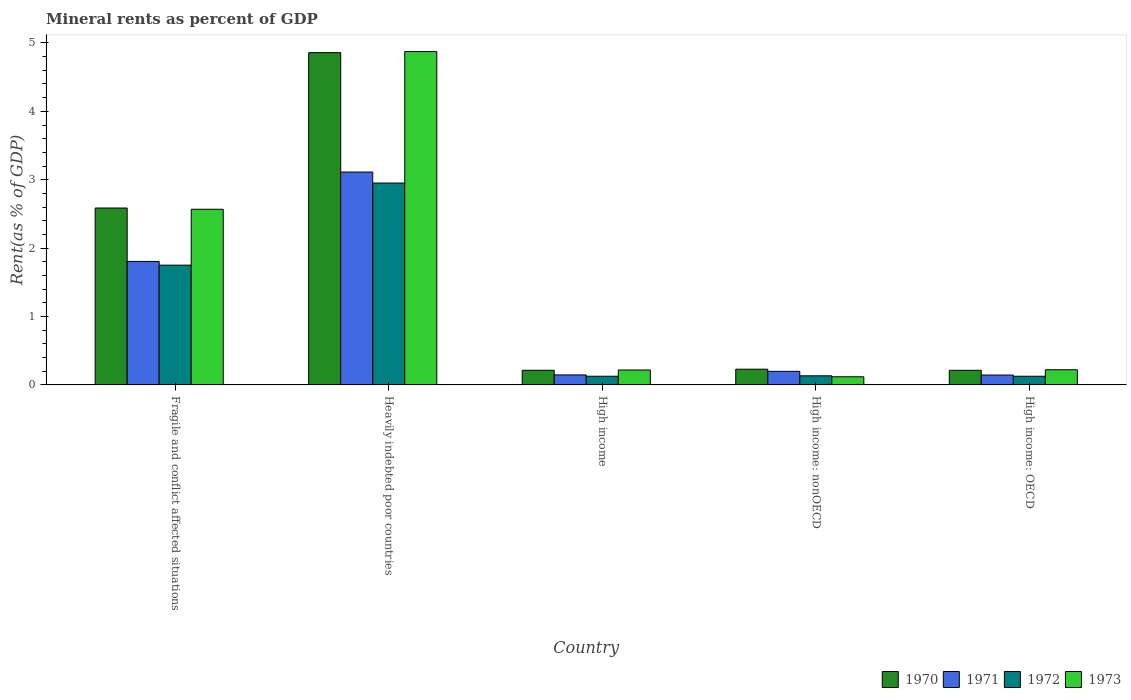Are the number of bars on each tick of the X-axis equal?
Ensure brevity in your answer.  Yes. What is the label of the 4th group of bars from the left?
Your answer should be compact. High income: nonOECD. What is the mineral rent in 1973 in High income: OECD?
Offer a very short reply. 0.22. Across all countries, what is the maximum mineral rent in 1972?
Give a very brief answer. 2.95. Across all countries, what is the minimum mineral rent in 1971?
Offer a terse response. 0.14. In which country was the mineral rent in 1970 maximum?
Your answer should be compact. Heavily indebted poor countries. In which country was the mineral rent in 1972 minimum?
Provide a succinct answer. High income: OECD. What is the total mineral rent in 1971 in the graph?
Provide a succinct answer. 5.41. What is the difference between the mineral rent in 1973 in Heavily indebted poor countries and that in High income: nonOECD?
Your answer should be compact. 4.75. What is the difference between the mineral rent in 1973 in High income and the mineral rent in 1970 in High income: OECD?
Provide a short and direct response. 0. What is the average mineral rent in 1973 per country?
Provide a succinct answer. 1.6. What is the difference between the mineral rent of/in 1972 and mineral rent of/in 1971 in Fragile and conflict affected situations?
Provide a succinct answer. -0.05. In how many countries, is the mineral rent in 1971 greater than 1.4 %?
Your answer should be compact. 2. What is the ratio of the mineral rent in 1973 in High income to that in High income: nonOECD?
Keep it short and to the point. 1.83. Is the mineral rent in 1970 in Heavily indebted poor countries less than that in High income: nonOECD?
Provide a short and direct response. No. Is the difference between the mineral rent in 1972 in Fragile and conflict affected situations and High income: OECD greater than the difference between the mineral rent in 1971 in Fragile and conflict affected situations and High income: OECD?
Provide a short and direct response. No. What is the difference between the highest and the second highest mineral rent in 1971?
Offer a terse response. -1.61. What is the difference between the highest and the lowest mineral rent in 1971?
Your answer should be very brief. 2.97. In how many countries, is the mineral rent in 1973 greater than the average mineral rent in 1973 taken over all countries?
Offer a very short reply. 2. Is the sum of the mineral rent in 1971 in Fragile and conflict affected situations and High income: OECD greater than the maximum mineral rent in 1970 across all countries?
Your answer should be compact. No. Is it the case that in every country, the sum of the mineral rent in 1973 and mineral rent in 1972 is greater than the sum of mineral rent in 1970 and mineral rent in 1971?
Offer a terse response. No. What does the 4th bar from the right in High income: OECD represents?
Give a very brief answer. 1970. Is it the case that in every country, the sum of the mineral rent in 1971 and mineral rent in 1973 is greater than the mineral rent in 1972?
Provide a short and direct response. Yes. Are all the bars in the graph horizontal?
Your answer should be very brief. No. What is the difference between two consecutive major ticks on the Y-axis?
Make the answer very short. 1. Does the graph contain any zero values?
Your answer should be compact. No. Where does the legend appear in the graph?
Ensure brevity in your answer.  Bottom right. How many legend labels are there?
Offer a very short reply. 4. How are the legend labels stacked?
Ensure brevity in your answer.  Horizontal. What is the title of the graph?
Offer a very short reply. Mineral rents as percent of GDP. What is the label or title of the Y-axis?
Provide a succinct answer. Rent(as % of GDP). What is the Rent(as % of GDP) of 1970 in Fragile and conflict affected situations?
Your answer should be compact. 2.59. What is the Rent(as % of GDP) in 1971 in Fragile and conflict affected situations?
Ensure brevity in your answer.  1.81. What is the Rent(as % of GDP) of 1972 in Fragile and conflict affected situations?
Give a very brief answer. 1.75. What is the Rent(as % of GDP) in 1973 in Fragile and conflict affected situations?
Offer a very short reply. 2.57. What is the Rent(as % of GDP) in 1970 in Heavily indebted poor countries?
Make the answer very short. 4.86. What is the Rent(as % of GDP) in 1971 in Heavily indebted poor countries?
Ensure brevity in your answer.  3.11. What is the Rent(as % of GDP) in 1972 in Heavily indebted poor countries?
Ensure brevity in your answer.  2.95. What is the Rent(as % of GDP) in 1973 in Heavily indebted poor countries?
Ensure brevity in your answer.  4.87. What is the Rent(as % of GDP) of 1970 in High income?
Provide a short and direct response. 0.21. What is the Rent(as % of GDP) of 1971 in High income?
Provide a short and direct response. 0.15. What is the Rent(as % of GDP) in 1972 in High income?
Provide a short and direct response. 0.13. What is the Rent(as % of GDP) of 1973 in High income?
Your response must be concise. 0.22. What is the Rent(as % of GDP) in 1970 in High income: nonOECD?
Ensure brevity in your answer.  0.23. What is the Rent(as % of GDP) of 1971 in High income: nonOECD?
Your answer should be very brief. 0.2. What is the Rent(as % of GDP) of 1972 in High income: nonOECD?
Provide a succinct answer. 0.13. What is the Rent(as % of GDP) in 1973 in High income: nonOECD?
Provide a short and direct response. 0.12. What is the Rent(as % of GDP) of 1970 in High income: OECD?
Provide a short and direct response. 0.21. What is the Rent(as % of GDP) of 1971 in High income: OECD?
Provide a short and direct response. 0.14. What is the Rent(as % of GDP) of 1972 in High income: OECD?
Provide a short and direct response. 0.13. What is the Rent(as % of GDP) of 1973 in High income: OECD?
Provide a short and direct response. 0.22. Across all countries, what is the maximum Rent(as % of GDP) in 1970?
Your response must be concise. 4.86. Across all countries, what is the maximum Rent(as % of GDP) of 1971?
Your answer should be compact. 3.11. Across all countries, what is the maximum Rent(as % of GDP) in 1972?
Your answer should be compact. 2.95. Across all countries, what is the maximum Rent(as % of GDP) in 1973?
Provide a succinct answer. 4.87. Across all countries, what is the minimum Rent(as % of GDP) in 1970?
Your response must be concise. 0.21. Across all countries, what is the minimum Rent(as % of GDP) in 1971?
Offer a very short reply. 0.14. Across all countries, what is the minimum Rent(as % of GDP) of 1972?
Give a very brief answer. 0.13. Across all countries, what is the minimum Rent(as % of GDP) of 1973?
Provide a succinct answer. 0.12. What is the total Rent(as % of GDP) in 1970 in the graph?
Ensure brevity in your answer.  8.1. What is the total Rent(as % of GDP) in 1971 in the graph?
Ensure brevity in your answer.  5.41. What is the total Rent(as % of GDP) in 1972 in the graph?
Give a very brief answer. 5.09. What is the total Rent(as % of GDP) in 1973 in the graph?
Your answer should be very brief. 8. What is the difference between the Rent(as % of GDP) in 1970 in Fragile and conflict affected situations and that in Heavily indebted poor countries?
Your answer should be very brief. -2.27. What is the difference between the Rent(as % of GDP) of 1971 in Fragile and conflict affected situations and that in Heavily indebted poor countries?
Offer a terse response. -1.31. What is the difference between the Rent(as % of GDP) in 1972 in Fragile and conflict affected situations and that in Heavily indebted poor countries?
Give a very brief answer. -1.2. What is the difference between the Rent(as % of GDP) in 1973 in Fragile and conflict affected situations and that in Heavily indebted poor countries?
Offer a terse response. -2.31. What is the difference between the Rent(as % of GDP) in 1970 in Fragile and conflict affected situations and that in High income?
Make the answer very short. 2.37. What is the difference between the Rent(as % of GDP) in 1971 in Fragile and conflict affected situations and that in High income?
Provide a short and direct response. 1.66. What is the difference between the Rent(as % of GDP) in 1972 in Fragile and conflict affected situations and that in High income?
Keep it short and to the point. 1.62. What is the difference between the Rent(as % of GDP) in 1973 in Fragile and conflict affected situations and that in High income?
Give a very brief answer. 2.35. What is the difference between the Rent(as % of GDP) of 1970 in Fragile and conflict affected situations and that in High income: nonOECD?
Keep it short and to the point. 2.36. What is the difference between the Rent(as % of GDP) of 1971 in Fragile and conflict affected situations and that in High income: nonOECD?
Give a very brief answer. 1.61. What is the difference between the Rent(as % of GDP) of 1972 in Fragile and conflict affected situations and that in High income: nonOECD?
Keep it short and to the point. 1.62. What is the difference between the Rent(as % of GDP) in 1973 in Fragile and conflict affected situations and that in High income: nonOECD?
Your response must be concise. 2.45. What is the difference between the Rent(as % of GDP) of 1970 in Fragile and conflict affected situations and that in High income: OECD?
Make the answer very short. 2.37. What is the difference between the Rent(as % of GDP) of 1971 in Fragile and conflict affected situations and that in High income: OECD?
Your response must be concise. 1.66. What is the difference between the Rent(as % of GDP) in 1972 in Fragile and conflict affected situations and that in High income: OECD?
Make the answer very short. 1.62. What is the difference between the Rent(as % of GDP) in 1973 in Fragile and conflict affected situations and that in High income: OECD?
Offer a terse response. 2.35. What is the difference between the Rent(as % of GDP) of 1970 in Heavily indebted poor countries and that in High income?
Provide a short and direct response. 4.64. What is the difference between the Rent(as % of GDP) of 1971 in Heavily indebted poor countries and that in High income?
Provide a succinct answer. 2.97. What is the difference between the Rent(as % of GDP) in 1972 in Heavily indebted poor countries and that in High income?
Your answer should be compact. 2.82. What is the difference between the Rent(as % of GDP) of 1973 in Heavily indebted poor countries and that in High income?
Offer a very short reply. 4.66. What is the difference between the Rent(as % of GDP) in 1970 in Heavily indebted poor countries and that in High income: nonOECD?
Make the answer very short. 4.63. What is the difference between the Rent(as % of GDP) in 1971 in Heavily indebted poor countries and that in High income: nonOECD?
Offer a terse response. 2.91. What is the difference between the Rent(as % of GDP) in 1972 in Heavily indebted poor countries and that in High income: nonOECD?
Your answer should be very brief. 2.82. What is the difference between the Rent(as % of GDP) in 1973 in Heavily indebted poor countries and that in High income: nonOECD?
Offer a terse response. 4.75. What is the difference between the Rent(as % of GDP) in 1970 in Heavily indebted poor countries and that in High income: OECD?
Keep it short and to the point. 4.64. What is the difference between the Rent(as % of GDP) of 1971 in Heavily indebted poor countries and that in High income: OECD?
Offer a terse response. 2.97. What is the difference between the Rent(as % of GDP) in 1972 in Heavily indebted poor countries and that in High income: OECD?
Ensure brevity in your answer.  2.83. What is the difference between the Rent(as % of GDP) of 1973 in Heavily indebted poor countries and that in High income: OECD?
Provide a succinct answer. 4.65. What is the difference between the Rent(as % of GDP) of 1970 in High income and that in High income: nonOECD?
Give a very brief answer. -0.02. What is the difference between the Rent(as % of GDP) in 1971 in High income and that in High income: nonOECD?
Your answer should be very brief. -0.05. What is the difference between the Rent(as % of GDP) of 1972 in High income and that in High income: nonOECD?
Provide a succinct answer. -0.01. What is the difference between the Rent(as % of GDP) of 1973 in High income and that in High income: nonOECD?
Provide a succinct answer. 0.1. What is the difference between the Rent(as % of GDP) in 1970 in High income and that in High income: OECD?
Offer a very short reply. 0. What is the difference between the Rent(as % of GDP) in 1971 in High income and that in High income: OECD?
Offer a very short reply. 0. What is the difference between the Rent(as % of GDP) of 1973 in High income and that in High income: OECD?
Your answer should be compact. -0. What is the difference between the Rent(as % of GDP) of 1970 in High income: nonOECD and that in High income: OECD?
Ensure brevity in your answer.  0.02. What is the difference between the Rent(as % of GDP) in 1971 in High income: nonOECD and that in High income: OECD?
Offer a very short reply. 0.05. What is the difference between the Rent(as % of GDP) in 1972 in High income: nonOECD and that in High income: OECD?
Offer a terse response. 0.01. What is the difference between the Rent(as % of GDP) of 1973 in High income: nonOECD and that in High income: OECD?
Your response must be concise. -0.1. What is the difference between the Rent(as % of GDP) of 1970 in Fragile and conflict affected situations and the Rent(as % of GDP) of 1971 in Heavily indebted poor countries?
Your response must be concise. -0.53. What is the difference between the Rent(as % of GDP) in 1970 in Fragile and conflict affected situations and the Rent(as % of GDP) in 1972 in Heavily indebted poor countries?
Ensure brevity in your answer.  -0.37. What is the difference between the Rent(as % of GDP) of 1970 in Fragile and conflict affected situations and the Rent(as % of GDP) of 1973 in Heavily indebted poor countries?
Offer a very short reply. -2.29. What is the difference between the Rent(as % of GDP) in 1971 in Fragile and conflict affected situations and the Rent(as % of GDP) in 1972 in Heavily indebted poor countries?
Your response must be concise. -1.15. What is the difference between the Rent(as % of GDP) of 1971 in Fragile and conflict affected situations and the Rent(as % of GDP) of 1973 in Heavily indebted poor countries?
Make the answer very short. -3.07. What is the difference between the Rent(as % of GDP) in 1972 in Fragile and conflict affected situations and the Rent(as % of GDP) in 1973 in Heavily indebted poor countries?
Keep it short and to the point. -3.12. What is the difference between the Rent(as % of GDP) of 1970 in Fragile and conflict affected situations and the Rent(as % of GDP) of 1971 in High income?
Your answer should be compact. 2.44. What is the difference between the Rent(as % of GDP) in 1970 in Fragile and conflict affected situations and the Rent(as % of GDP) in 1972 in High income?
Your answer should be very brief. 2.46. What is the difference between the Rent(as % of GDP) in 1970 in Fragile and conflict affected situations and the Rent(as % of GDP) in 1973 in High income?
Your response must be concise. 2.37. What is the difference between the Rent(as % of GDP) of 1971 in Fragile and conflict affected situations and the Rent(as % of GDP) of 1972 in High income?
Keep it short and to the point. 1.68. What is the difference between the Rent(as % of GDP) of 1971 in Fragile and conflict affected situations and the Rent(as % of GDP) of 1973 in High income?
Offer a very short reply. 1.59. What is the difference between the Rent(as % of GDP) of 1972 in Fragile and conflict affected situations and the Rent(as % of GDP) of 1973 in High income?
Your response must be concise. 1.53. What is the difference between the Rent(as % of GDP) of 1970 in Fragile and conflict affected situations and the Rent(as % of GDP) of 1971 in High income: nonOECD?
Provide a short and direct response. 2.39. What is the difference between the Rent(as % of GDP) in 1970 in Fragile and conflict affected situations and the Rent(as % of GDP) in 1972 in High income: nonOECD?
Your answer should be very brief. 2.45. What is the difference between the Rent(as % of GDP) in 1970 in Fragile and conflict affected situations and the Rent(as % of GDP) in 1973 in High income: nonOECD?
Offer a terse response. 2.47. What is the difference between the Rent(as % of GDP) in 1971 in Fragile and conflict affected situations and the Rent(as % of GDP) in 1972 in High income: nonOECD?
Make the answer very short. 1.67. What is the difference between the Rent(as % of GDP) of 1971 in Fragile and conflict affected situations and the Rent(as % of GDP) of 1973 in High income: nonOECD?
Offer a very short reply. 1.69. What is the difference between the Rent(as % of GDP) in 1972 in Fragile and conflict affected situations and the Rent(as % of GDP) in 1973 in High income: nonOECD?
Your answer should be very brief. 1.63. What is the difference between the Rent(as % of GDP) in 1970 in Fragile and conflict affected situations and the Rent(as % of GDP) in 1971 in High income: OECD?
Ensure brevity in your answer.  2.44. What is the difference between the Rent(as % of GDP) in 1970 in Fragile and conflict affected situations and the Rent(as % of GDP) in 1972 in High income: OECD?
Offer a terse response. 2.46. What is the difference between the Rent(as % of GDP) of 1970 in Fragile and conflict affected situations and the Rent(as % of GDP) of 1973 in High income: OECD?
Ensure brevity in your answer.  2.36. What is the difference between the Rent(as % of GDP) of 1971 in Fragile and conflict affected situations and the Rent(as % of GDP) of 1972 in High income: OECD?
Give a very brief answer. 1.68. What is the difference between the Rent(as % of GDP) in 1971 in Fragile and conflict affected situations and the Rent(as % of GDP) in 1973 in High income: OECD?
Ensure brevity in your answer.  1.58. What is the difference between the Rent(as % of GDP) in 1972 in Fragile and conflict affected situations and the Rent(as % of GDP) in 1973 in High income: OECD?
Provide a short and direct response. 1.53. What is the difference between the Rent(as % of GDP) of 1970 in Heavily indebted poor countries and the Rent(as % of GDP) of 1971 in High income?
Provide a succinct answer. 4.71. What is the difference between the Rent(as % of GDP) of 1970 in Heavily indebted poor countries and the Rent(as % of GDP) of 1972 in High income?
Provide a short and direct response. 4.73. What is the difference between the Rent(as % of GDP) in 1970 in Heavily indebted poor countries and the Rent(as % of GDP) in 1973 in High income?
Offer a very short reply. 4.64. What is the difference between the Rent(as % of GDP) in 1971 in Heavily indebted poor countries and the Rent(as % of GDP) in 1972 in High income?
Ensure brevity in your answer.  2.99. What is the difference between the Rent(as % of GDP) of 1971 in Heavily indebted poor countries and the Rent(as % of GDP) of 1973 in High income?
Provide a short and direct response. 2.89. What is the difference between the Rent(as % of GDP) in 1972 in Heavily indebted poor countries and the Rent(as % of GDP) in 1973 in High income?
Provide a short and direct response. 2.73. What is the difference between the Rent(as % of GDP) in 1970 in Heavily indebted poor countries and the Rent(as % of GDP) in 1971 in High income: nonOECD?
Your response must be concise. 4.66. What is the difference between the Rent(as % of GDP) in 1970 in Heavily indebted poor countries and the Rent(as % of GDP) in 1972 in High income: nonOECD?
Offer a very short reply. 4.72. What is the difference between the Rent(as % of GDP) of 1970 in Heavily indebted poor countries and the Rent(as % of GDP) of 1973 in High income: nonOECD?
Ensure brevity in your answer.  4.74. What is the difference between the Rent(as % of GDP) in 1971 in Heavily indebted poor countries and the Rent(as % of GDP) in 1972 in High income: nonOECD?
Offer a very short reply. 2.98. What is the difference between the Rent(as % of GDP) in 1971 in Heavily indebted poor countries and the Rent(as % of GDP) in 1973 in High income: nonOECD?
Offer a terse response. 2.99. What is the difference between the Rent(as % of GDP) of 1972 in Heavily indebted poor countries and the Rent(as % of GDP) of 1973 in High income: nonOECD?
Offer a terse response. 2.83. What is the difference between the Rent(as % of GDP) in 1970 in Heavily indebted poor countries and the Rent(as % of GDP) in 1971 in High income: OECD?
Offer a terse response. 4.71. What is the difference between the Rent(as % of GDP) of 1970 in Heavily indebted poor countries and the Rent(as % of GDP) of 1972 in High income: OECD?
Offer a terse response. 4.73. What is the difference between the Rent(as % of GDP) in 1970 in Heavily indebted poor countries and the Rent(as % of GDP) in 1973 in High income: OECD?
Offer a very short reply. 4.64. What is the difference between the Rent(as % of GDP) of 1971 in Heavily indebted poor countries and the Rent(as % of GDP) of 1972 in High income: OECD?
Provide a short and direct response. 2.99. What is the difference between the Rent(as % of GDP) of 1971 in Heavily indebted poor countries and the Rent(as % of GDP) of 1973 in High income: OECD?
Your answer should be very brief. 2.89. What is the difference between the Rent(as % of GDP) of 1972 in Heavily indebted poor countries and the Rent(as % of GDP) of 1973 in High income: OECD?
Your answer should be compact. 2.73. What is the difference between the Rent(as % of GDP) of 1970 in High income and the Rent(as % of GDP) of 1971 in High income: nonOECD?
Ensure brevity in your answer.  0.02. What is the difference between the Rent(as % of GDP) of 1970 in High income and the Rent(as % of GDP) of 1972 in High income: nonOECD?
Keep it short and to the point. 0.08. What is the difference between the Rent(as % of GDP) in 1970 in High income and the Rent(as % of GDP) in 1973 in High income: nonOECD?
Your answer should be very brief. 0.1. What is the difference between the Rent(as % of GDP) in 1971 in High income and the Rent(as % of GDP) in 1972 in High income: nonOECD?
Ensure brevity in your answer.  0.01. What is the difference between the Rent(as % of GDP) of 1971 in High income and the Rent(as % of GDP) of 1973 in High income: nonOECD?
Give a very brief answer. 0.03. What is the difference between the Rent(as % of GDP) in 1972 in High income and the Rent(as % of GDP) in 1973 in High income: nonOECD?
Give a very brief answer. 0.01. What is the difference between the Rent(as % of GDP) of 1970 in High income and the Rent(as % of GDP) of 1971 in High income: OECD?
Your answer should be compact. 0.07. What is the difference between the Rent(as % of GDP) in 1970 in High income and the Rent(as % of GDP) in 1972 in High income: OECD?
Make the answer very short. 0.09. What is the difference between the Rent(as % of GDP) in 1970 in High income and the Rent(as % of GDP) in 1973 in High income: OECD?
Give a very brief answer. -0.01. What is the difference between the Rent(as % of GDP) of 1971 in High income and the Rent(as % of GDP) of 1972 in High income: OECD?
Offer a very short reply. 0.02. What is the difference between the Rent(as % of GDP) of 1971 in High income and the Rent(as % of GDP) of 1973 in High income: OECD?
Keep it short and to the point. -0.08. What is the difference between the Rent(as % of GDP) of 1972 in High income and the Rent(as % of GDP) of 1973 in High income: OECD?
Your answer should be compact. -0.1. What is the difference between the Rent(as % of GDP) in 1970 in High income: nonOECD and the Rent(as % of GDP) in 1971 in High income: OECD?
Keep it short and to the point. 0.09. What is the difference between the Rent(as % of GDP) of 1970 in High income: nonOECD and the Rent(as % of GDP) of 1972 in High income: OECD?
Your answer should be very brief. 0.1. What is the difference between the Rent(as % of GDP) of 1970 in High income: nonOECD and the Rent(as % of GDP) of 1973 in High income: OECD?
Ensure brevity in your answer.  0.01. What is the difference between the Rent(as % of GDP) of 1971 in High income: nonOECD and the Rent(as % of GDP) of 1972 in High income: OECD?
Your answer should be very brief. 0.07. What is the difference between the Rent(as % of GDP) of 1971 in High income: nonOECD and the Rent(as % of GDP) of 1973 in High income: OECD?
Provide a short and direct response. -0.02. What is the difference between the Rent(as % of GDP) of 1972 in High income: nonOECD and the Rent(as % of GDP) of 1973 in High income: OECD?
Your answer should be compact. -0.09. What is the average Rent(as % of GDP) in 1970 per country?
Offer a terse response. 1.62. What is the average Rent(as % of GDP) in 1971 per country?
Your answer should be very brief. 1.08. What is the average Rent(as % of GDP) of 1972 per country?
Offer a very short reply. 1.02. What is the average Rent(as % of GDP) of 1973 per country?
Your response must be concise. 1.6. What is the difference between the Rent(as % of GDP) of 1970 and Rent(as % of GDP) of 1971 in Fragile and conflict affected situations?
Provide a short and direct response. 0.78. What is the difference between the Rent(as % of GDP) in 1970 and Rent(as % of GDP) in 1972 in Fragile and conflict affected situations?
Make the answer very short. 0.84. What is the difference between the Rent(as % of GDP) of 1970 and Rent(as % of GDP) of 1973 in Fragile and conflict affected situations?
Make the answer very short. 0.02. What is the difference between the Rent(as % of GDP) in 1971 and Rent(as % of GDP) in 1972 in Fragile and conflict affected situations?
Ensure brevity in your answer.  0.05. What is the difference between the Rent(as % of GDP) in 1971 and Rent(as % of GDP) in 1973 in Fragile and conflict affected situations?
Your answer should be very brief. -0.76. What is the difference between the Rent(as % of GDP) in 1972 and Rent(as % of GDP) in 1973 in Fragile and conflict affected situations?
Offer a very short reply. -0.82. What is the difference between the Rent(as % of GDP) in 1970 and Rent(as % of GDP) in 1971 in Heavily indebted poor countries?
Provide a short and direct response. 1.75. What is the difference between the Rent(as % of GDP) of 1970 and Rent(as % of GDP) of 1972 in Heavily indebted poor countries?
Your response must be concise. 1.91. What is the difference between the Rent(as % of GDP) in 1970 and Rent(as % of GDP) in 1973 in Heavily indebted poor countries?
Give a very brief answer. -0.02. What is the difference between the Rent(as % of GDP) of 1971 and Rent(as % of GDP) of 1972 in Heavily indebted poor countries?
Ensure brevity in your answer.  0.16. What is the difference between the Rent(as % of GDP) of 1971 and Rent(as % of GDP) of 1973 in Heavily indebted poor countries?
Your answer should be very brief. -1.76. What is the difference between the Rent(as % of GDP) of 1972 and Rent(as % of GDP) of 1973 in Heavily indebted poor countries?
Your answer should be compact. -1.92. What is the difference between the Rent(as % of GDP) in 1970 and Rent(as % of GDP) in 1971 in High income?
Make the answer very short. 0.07. What is the difference between the Rent(as % of GDP) in 1970 and Rent(as % of GDP) in 1972 in High income?
Give a very brief answer. 0.09. What is the difference between the Rent(as % of GDP) of 1970 and Rent(as % of GDP) of 1973 in High income?
Provide a succinct answer. -0. What is the difference between the Rent(as % of GDP) of 1971 and Rent(as % of GDP) of 1972 in High income?
Ensure brevity in your answer.  0.02. What is the difference between the Rent(as % of GDP) in 1971 and Rent(as % of GDP) in 1973 in High income?
Offer a terse response. -0.07. What is the difference between the Rent(as % of GDP) in 1972 and Rent(as % of GDP) in 1973 in High income?
Offer a terse response. -0.09. What is the difference between the Rent(as % of GDP) in 1970 and Rent(as % of GDP) in 1971 in High income: nonOECD?
Provide a short and direct response. 0.03. What is the difference between the Rent(as % of GDP) in 1970 and Rent(as % of GDP) in 1972 in High income: nonOECD?
Make the answer very short. 0.1. What is the difference between the Rent(as % of GDP) in 1970 and Rent(as % of GDP) in 1973 in High income: nonOECD?
Provide a short and direct response. 0.11. What is the difference between the Rent(as % of GDP) in 1971 and Rent(as % of GDP) in 1972 in High income: nonOECD?
Offer a terse response. 0.07. What is the difference between the Rent(as % of GDP) of 1971 and Rent(as % of GDP) of 1973 in High income: nonOECD?
Your response must be concise. 0.08. What is the difference between the Rent(as % of GDP) in 1972 and Rent(as % of GDP) in 1973 in High income: nonOECD?
Keep it short and to the point. 0.01. What is the difference between the Rent(as % of GDP) in 1970 and Rent(as % of GDP) in 1971 in High income: OECD?
Provide a succinct answer. 0.07. What is the difference between the Rent(as % of GDP) of 1970 and Rent(as % of GDP) of 1972 in High income: OECD?
Offer a very short reply. 0.09. What is the difference between the Rent(as % of GDP) in 1970 and Rent(as % of GDP) in 1973 in High income: OECD?
Ensure brevity in your answer.  -0.01. What is the difference between the Rent(as % of GDP) in 1971 and Rent(as % of GDP) in 1972 in High income: OECD?
Keep it short and to the point. 0.02. What is the difference between the Rent(as % of GDP) of 1971 and Rent(as % of GDP) of 1973 in High income: OECD?
Keep it short and to the point. -0.08. What is the difference between the Rent(as % of GDP) of 1972 and Rent(as % of GDP) of 1973 in High income: OECD?
Your answer should be compact. -0.1. What is the ratio of the Rent(as % of GDP) in 1970 in Fragile and conflict affected situations to that in Heavily indebted poor countries?
Offer a very short reply. 0.53. What is the ratio of the Rent(as % of GDP) in 1971 in Fragile and conflict affected situations to that in Heavily indebted poor countries?
Your answer should be very brief. 0.58. What is the ratio of the Rent(as % of GDP) in 1972 in Fragile and conflict affected situations to that in Heavily indebted poor countries?
Give a very brief answer. 0.59. What is the ratio of the Rent(as % of GDP) in 1973 in Fragile and conflict affected situations to that in Heavily indebted poor countries?
Keep it short and to the point. 0.53. What is the ratio of the Rent(as % of GDP) in 1970 in Fragile and conflict affected situations to that in High income?
Give a very brief answer. 12.08. What is the ratio of the Rent(as % of GDP) of 1971 in Fragile and conflict affected situations to that in High income?
Make the answer very short. 12.36. What is the ratio of the Rent(as % of GDP) in 1972 in Fragile and conflict affected situations to that in High income?
Your answer should be compact. 13.82. What is the ratio of the Rent(as % of GDP) of 1973 in Fragile and conflict affected situations to that in High income?
Offer a very short reply. 11.78. What is the ratio of the Rent(as % of GDP) of 1970 in Fragile and conflict affected situations to that in High income: nonOECD?
Offer a very short reply. 11.26. What is the ratio of the Rent(as % of GDP) of 1971 in Fragile and conflict affected situations to that in High income: nonOECD?
Keep it short and to the point. 9.09. What is the ratio of the Rent(as % of GDP) of 1972 in Fragile and conflict affected situations to that in High income: nonOECD?
Your response must be concise. 13.15. What is the ratio of the Rent(as % of GDP) in 1973 in Fragile and conflict affected situations to that in High income: nonOECD?
Offer a very short reply. 21.58. What is the ratio of the Rent(as % of GDP) in 1970 in Fragile and conflict affected situations to that in High income: OECD?
Give a very brief answer. 12.11. What is the ratio of the Rent(as % of GDP) in 1971 in Fragile and conflict affected situations to that in High income: OECD?
Provide a short and direct response. 12.51. What is the ratio of the Rent(as % of GDP) in 1972 in Fragile and conflict affected situations to that in High income: OECD?
Give a very brief answer. 13.85. What is the ratio of the Rent(as % of GDP) of 1973 in Fragile and conflict affected situations to that in High income: OECD?
Provide a succinct answer. 11.58. What is the ratio of the Rent(as % of GDP) of 1970 in Heavily indebted poor countries to that in High income?
Provide a succinct answer. 22.69. What is the ratio of the Rent(as % of GDP) in 1971 in Heavily indebted poor countries to that in High income?
Provide a short and direct response. 21.31. What is the ratio of the Rent(as % of GDP) of 1972 in Heavily indebted poor countries to that in High income?
Your answer should be compact. 23.3. What is the ratio of the Rent(as % of GDP) in 1973 in Heavily indebted poor countries to that in High income?
Your answer should be compact. 22.35. What is the ratio of the Rent(as % of GDP) of 1970 in Heavily indebted poor countries to that in High income: nonOECD?
Offer a terse response. 21.14. What is the ratio of the Rent(as % of GDP) of 1971 in Heavily indebted poor countries to that in High income: nonOECD?
Make the answer very short. 15.68. What is the ratio of the Rent(as % of GDP) in 1972 in Heavily indebted poor countries to that in High income: nonOECD?
Provide a succinct answer. 22.17. What is the ratio of the Rent(as % of GDP) in 1973 in Heavily indebted poor countries to that in High income: nonOECD?
Your answer should be very brief. 40.95. What is the ratio of the Rent(as % of GDP) of 1970 in Heavily indebted poor countries to that in High income: OECD?
Keep it short and to the point. 22.74. What is the ratio of the Rent(as % of GDP) in 1971 in Heavily indebted poor countries to that in High income: OECD?
Offer a terse response. 21.57. What is the ratio of the Rent(as % of GDP) in 1972 in Heavily indebted poor countries to that in High income: OECD?
Ensure brevity in your answer.  23.34. What is the ratio of the Rent(as % of GDP) in 1973 in Heavily indebted poor countries to that in High income: OECD?
Your answer should be very brief. 21.98. What is the ratio of the Rent(as % of GDP) of 1970 in High income to that in High income: nonOECD?
Make the answer very short. 0.93. What is the ratio of the Rent(as % of GDP) in 1971 in High income to that in High income: nonOECD?
Ensure brevity in your answer.  0.74. What is the ratio of the Rent(as % of GDP) in 1972 in High income to that in High income: nonOECD?
Your response must be concise. 0.95. What is the ratio of the Rent(as % of GDP) in 1973 in High income to that in High income: nonOECD?
Provide a short and direct response. 1.83. What is the ratio of the Rent(as % of GDP) in 1970 in High income to that in High income: OECD?
Provide a succinct answer. 1. What is the ratio of the Rent(as % of GDP) in 1971 in High income to that in High income: OECD?
Make the answer very short. 1.01. What is the ratio of the Rent(as % of GDP) in 1973 in High income to that in High income: OECD?
Your answer should be compact. 0.98. What is the ratio of the Rent(as % of GDP) of 1970 in High income: nonOECD to that in High income: OECD?
Provide a succinct answer. 1.08. What is the ratio of the Rent(as % of GDP) in 1971 in High income: nonOECD to that in High income: OECD?
Offer a very short reply. 1.38. What is the ratio of the Rent(as % of GDP) in 1972 in High income: nonOECD to that in High income: OECD?
Give a very brief answer. 1.05. What is the ratio of the Rent(as % of GDP) in 1973 in High income: nonOECD to that in High income: OECD?
Ensure brevity in your answer.  0.54. What is the difference between the highest and the second highest Rent(as % of GDP) of 1970?
Give a very brief answer. 2.27. What is the difference between the highest and the second highest Rent(as % of GDP) in 1971?
Offer a terse response. 1.31. What is the difference between the highest and the second highest Rent(as % of GDP) of 1972?
Your response must be concise. 1.2. What is the difference between the highest and the second highest Rent(as % of GDP) of 1973?
Make the answer very short. 2.31. What is the difference between the highest and the lowest Rent(as % of GDP) in 1970?
Provide a succinct answer. 4.64. What is the difference between the highest and the lowest Rent(as % of GDP) of 1971?
Offer a very short reply. 2.97. What is the difference between the highest and the lowest Rent(as % of GDP) in 1972?
Your answer should be compact. 2.83. What is the difference between the highest and the lowest Rent(as % of GDP) in 1973?
Provide a short and direct response. 4.75. 